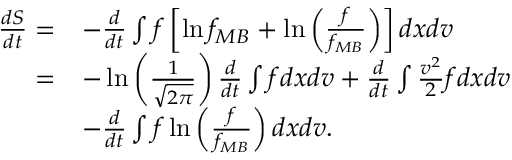<formula> <loc_0><loc_0><loc_500><loc_500>\begin{array} { r l } { \frac { d S } { d t } = } & { - \frac { d } { d t } \int f \left [ \ln f _ { M B } + \ln \left ( \frac { f } { f _ { M B } } \right ) \right ] d x d v } \\ { = } & { - \ln \left ( \frac { 1 } { \sqrt { 2 \pi } } \right ) \frac { d } { d t } \int f d x d v + \frac { d } { d t } \int \frac { v ^ { 2 } } { 2 } f d x d v } \\ & { - \frac { d } { d t } \int f \ln \left ( \frac { f } { f _ { M B } } \right ) d x d v . } \end{array}</formula> 